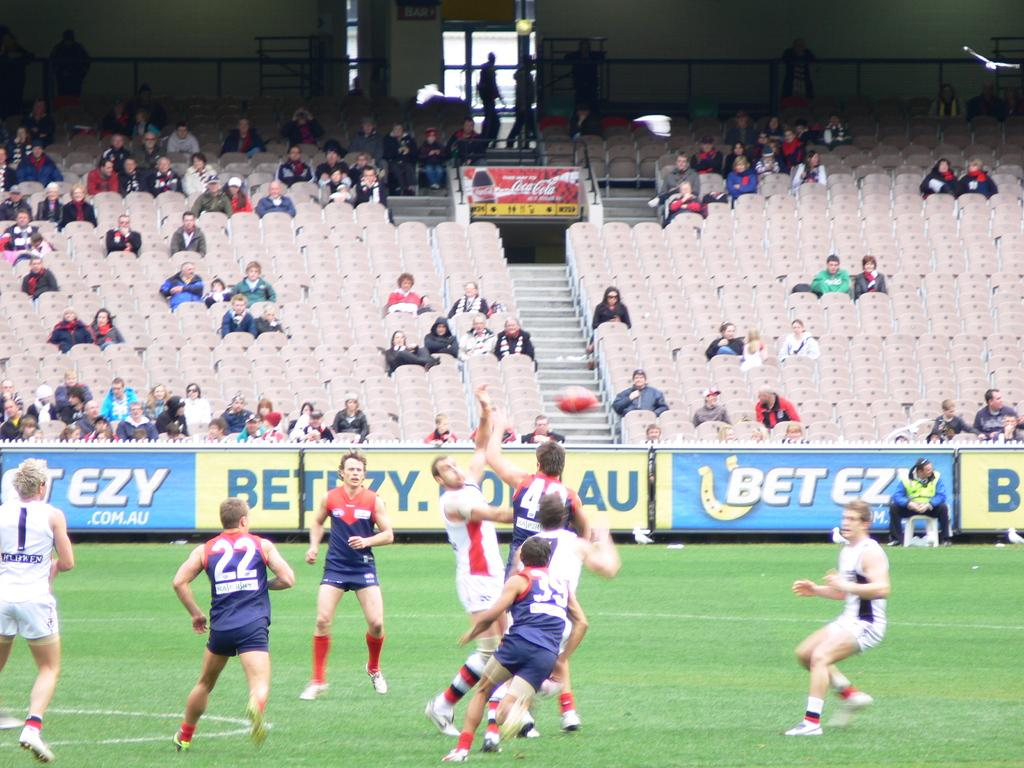What are the people in the image doing? The people in the image are walking. What can be seen beneath the people's feet in the image? The ground is visible in the image. Are there any people sitting down in the image? Yes, there are people sitting on chairs in the image. What object can be seen in the image besides the people? There is a bottle in the image. What type of cakes are the people in the image deciding to cook? There are no cakes or cooking activities present in the image. What decision are the people in the image making? The provided facts do not indicate that the people in the image are making any decisions. 